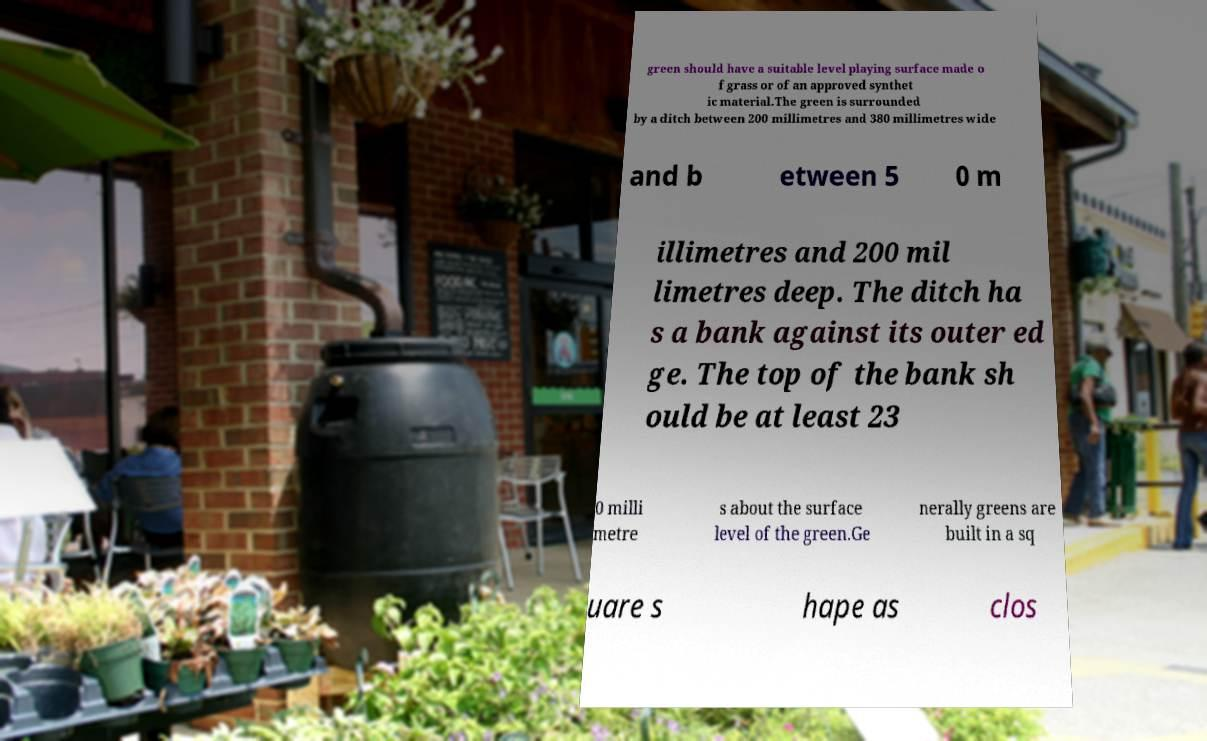There's text embedded in this image that I need extracted. Can you transcribe it verbatim? green should have a suitable level playing surface made o f grass or of an approved synthet ic material.The green is surrounded by a ditch between 200 millimetres and 380 millimetres wide and b etween 5 0 m illimetres and 200 mil limetres deep. The ditch ha s a bank against its outer ed ge. The top of the bank sh ould be at least 23 0 milli metre s about the surface level of the green.Ge nerally greens are built in a sq uare s hape as clos 